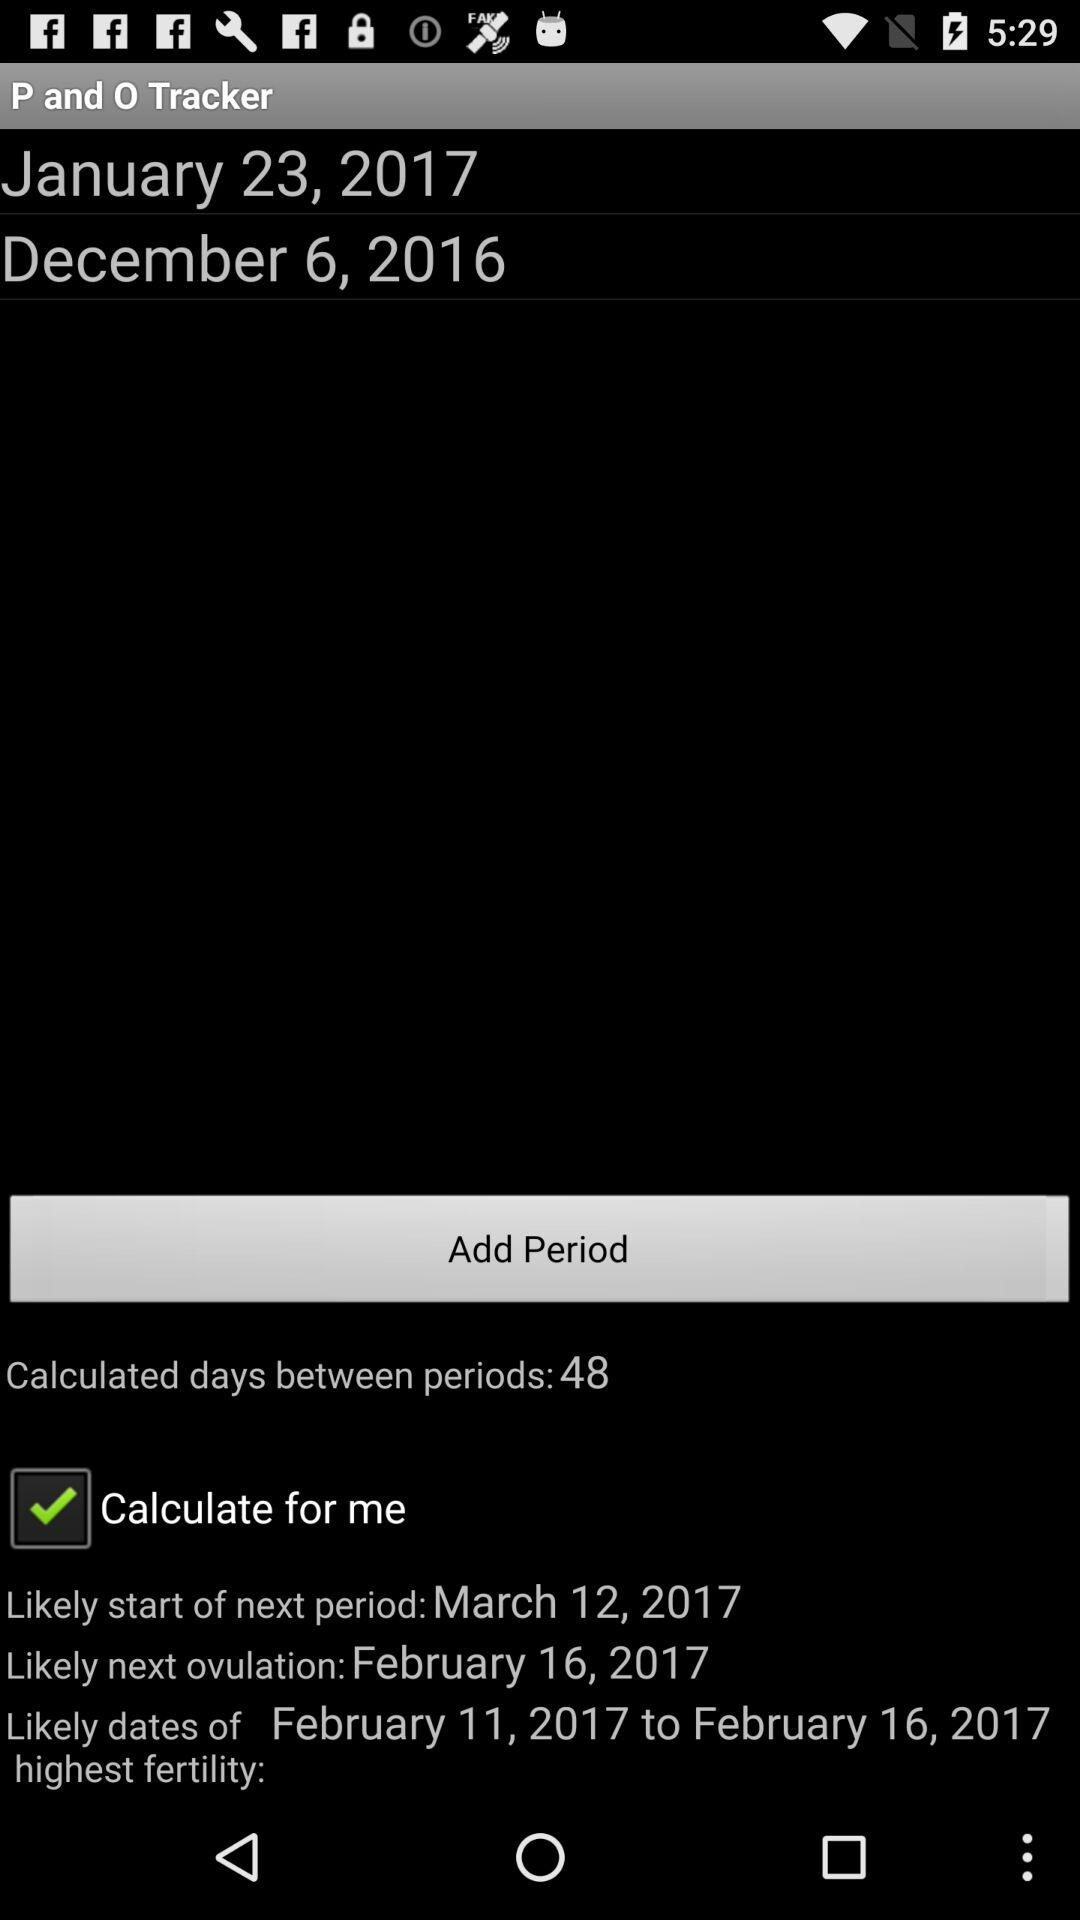How many days between the two most recent periods?
Answer the question using a single word or phrase. 48 